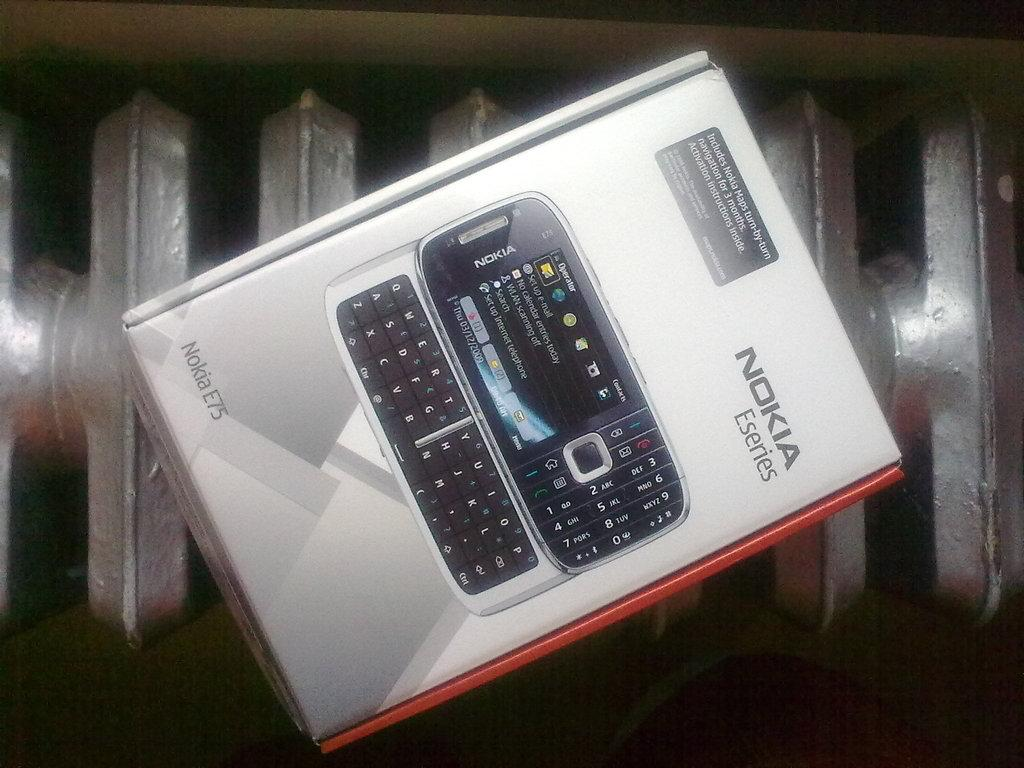What object is present in the image? There is a box in the image. Where is the box located? The box is on a surface. What is depicted on the box? There is a mobile phone printed on the box. Are there any words or letters on the box? Yes, there is text on the box. How many ladybugs can be seen crawling on the box in the image? There are no ladybugs present on the box in the image. What type of park is visible in the background of the image? There is no park visible in the image; it only features a box. 